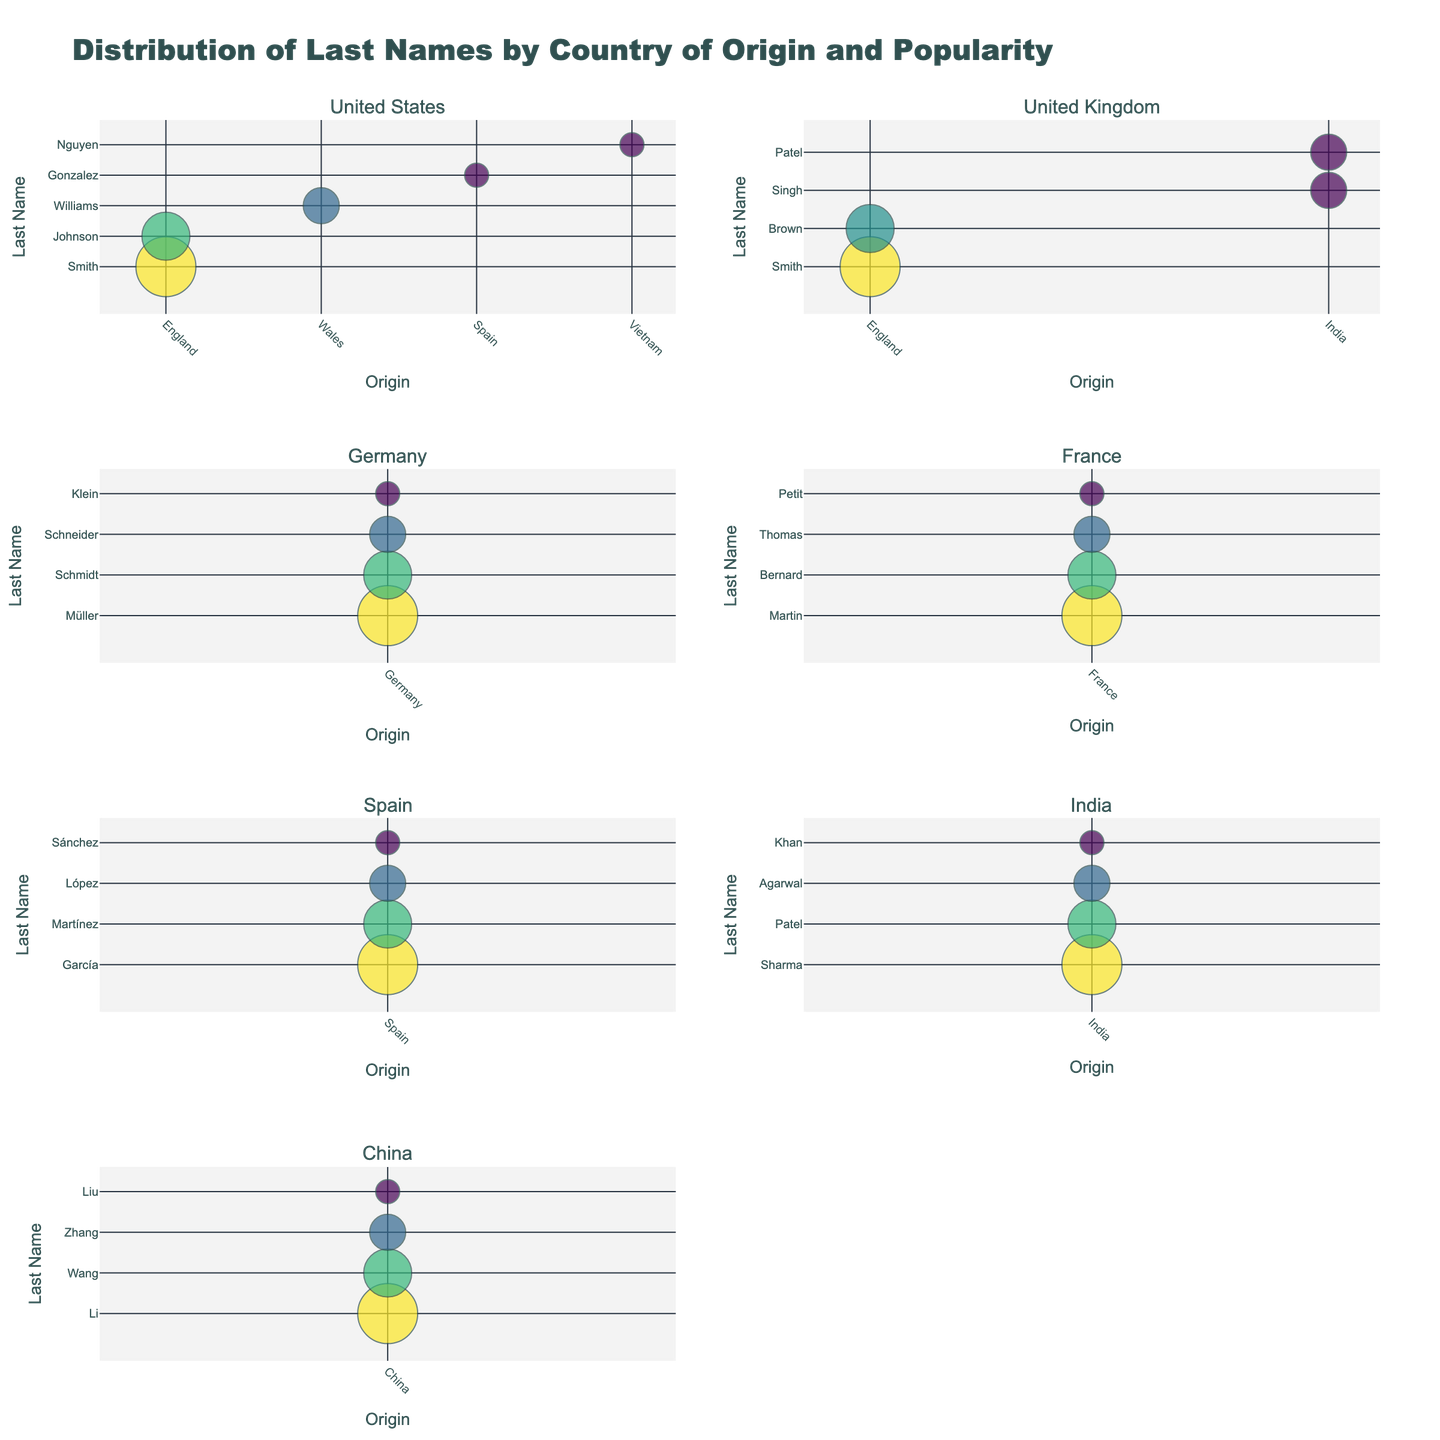What is the title of the chart? The title of the chart can be found at the top of the figure. It typically describes the overall content or purpose of the chart.
Answer: Distribution of Last Names by Country of Origin and Popularity How many countries are represented in the chart? Each subplot with last names and origins represents a different country. Count the subplot titles to determine the number of countries.
Answer: 7 Which origin has caused the most overlapping bubbles in the United States subplot? To find this, look at the size and position of bubbles in the United States subplot. Identify the origin where multiple bubbles overlap.
Answer: England Which country has a last name with a popularity rating of 5 that originates from Germany? Locate the subplots and identify which contains a bubble with the largest size (indicating a popularity rating of 5) that has the origin marked as "Germany."
Answer: Germany Which two countries have the last name "Patel" listed, and what are their origins? Look for bubbles labeled "Patel" in the subplots and check their corresponding origins and countries.
Answer: United Kingdom, India and both originating from India In which country does the last name "Nguyen" appear, and what is its origin? Identify the subplot that contains a bubble labeled "Nguyen" and note its origin.
Answer: United States, Vietnam Compare the popularity of the last name "Martin" in France to the popularity of "García" in Spain. Which one is higher? Find the bubbles labeled "Martin" in the France subplot and "García" in the Spain subplot. Compare their sizes to determine which has higher popularity.
Answer: Both have the same popularity (5) What is the smallest popularity rating represented in the China subplot, and which last name does it correspond to? Observe the size of bubbles in the China subplot. The smallest bubbles will indicate the lowest popularity rating. Identify the last name associated with the smallest bubble.
Answer: 2, Liu What is the total number of unique last names in the Indian and French subplots combined? Count the distinct bubbles (each representing a unique last name) in both the Indian and French subplots.
Answer: 8 Which country's subplot contains the most diverse origins for last names? Examine the x-axis (origin) labels for each country's subplot and determine which has the largest number of different origins represented.
Answer: United States 